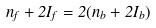<formula> <loc_0><loc_0><loc_500><loc_500>n _ { f } + 2 I _ { f } = 2 ( n _ { b } + 2 I _ { b } )</formula> 